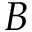<formula> <loc_0><loc_0><loc_500><loc_500>B</formula> 